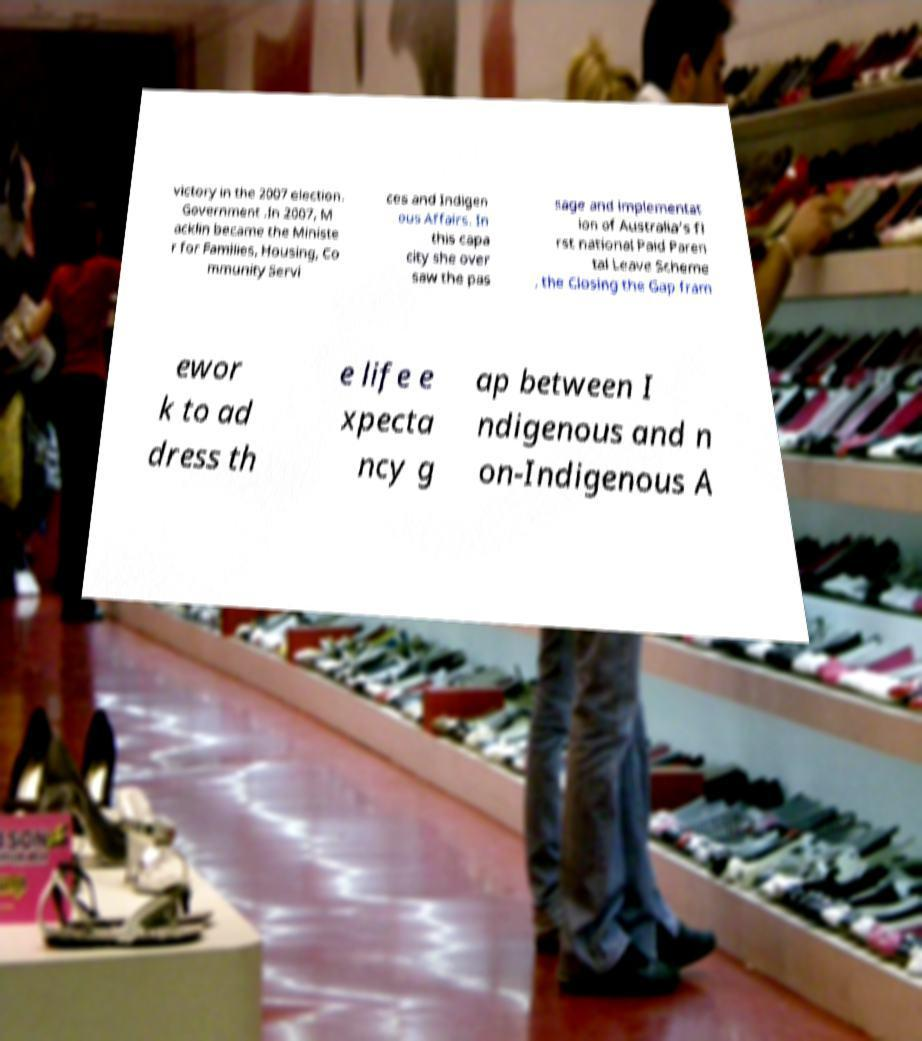Can you read and provide the text displayed in the image?This photo seems to have some interesting text. Can you extract and type it out for me? victory in the 2007 election. Government .In 2007, M acklin became the Ministe r for Families, Housing, Co mmunity Servi ces and Indigen ous Affairs. In this capa city she over saw the pas sage and implementat ion of Australia's fi rst national Paid Paren tal Leave Scheme , the Closing the Gap fram ewor k to ad dress th e life e xpecta ncy g ap between I ndigenous and n on-Indigenous A 